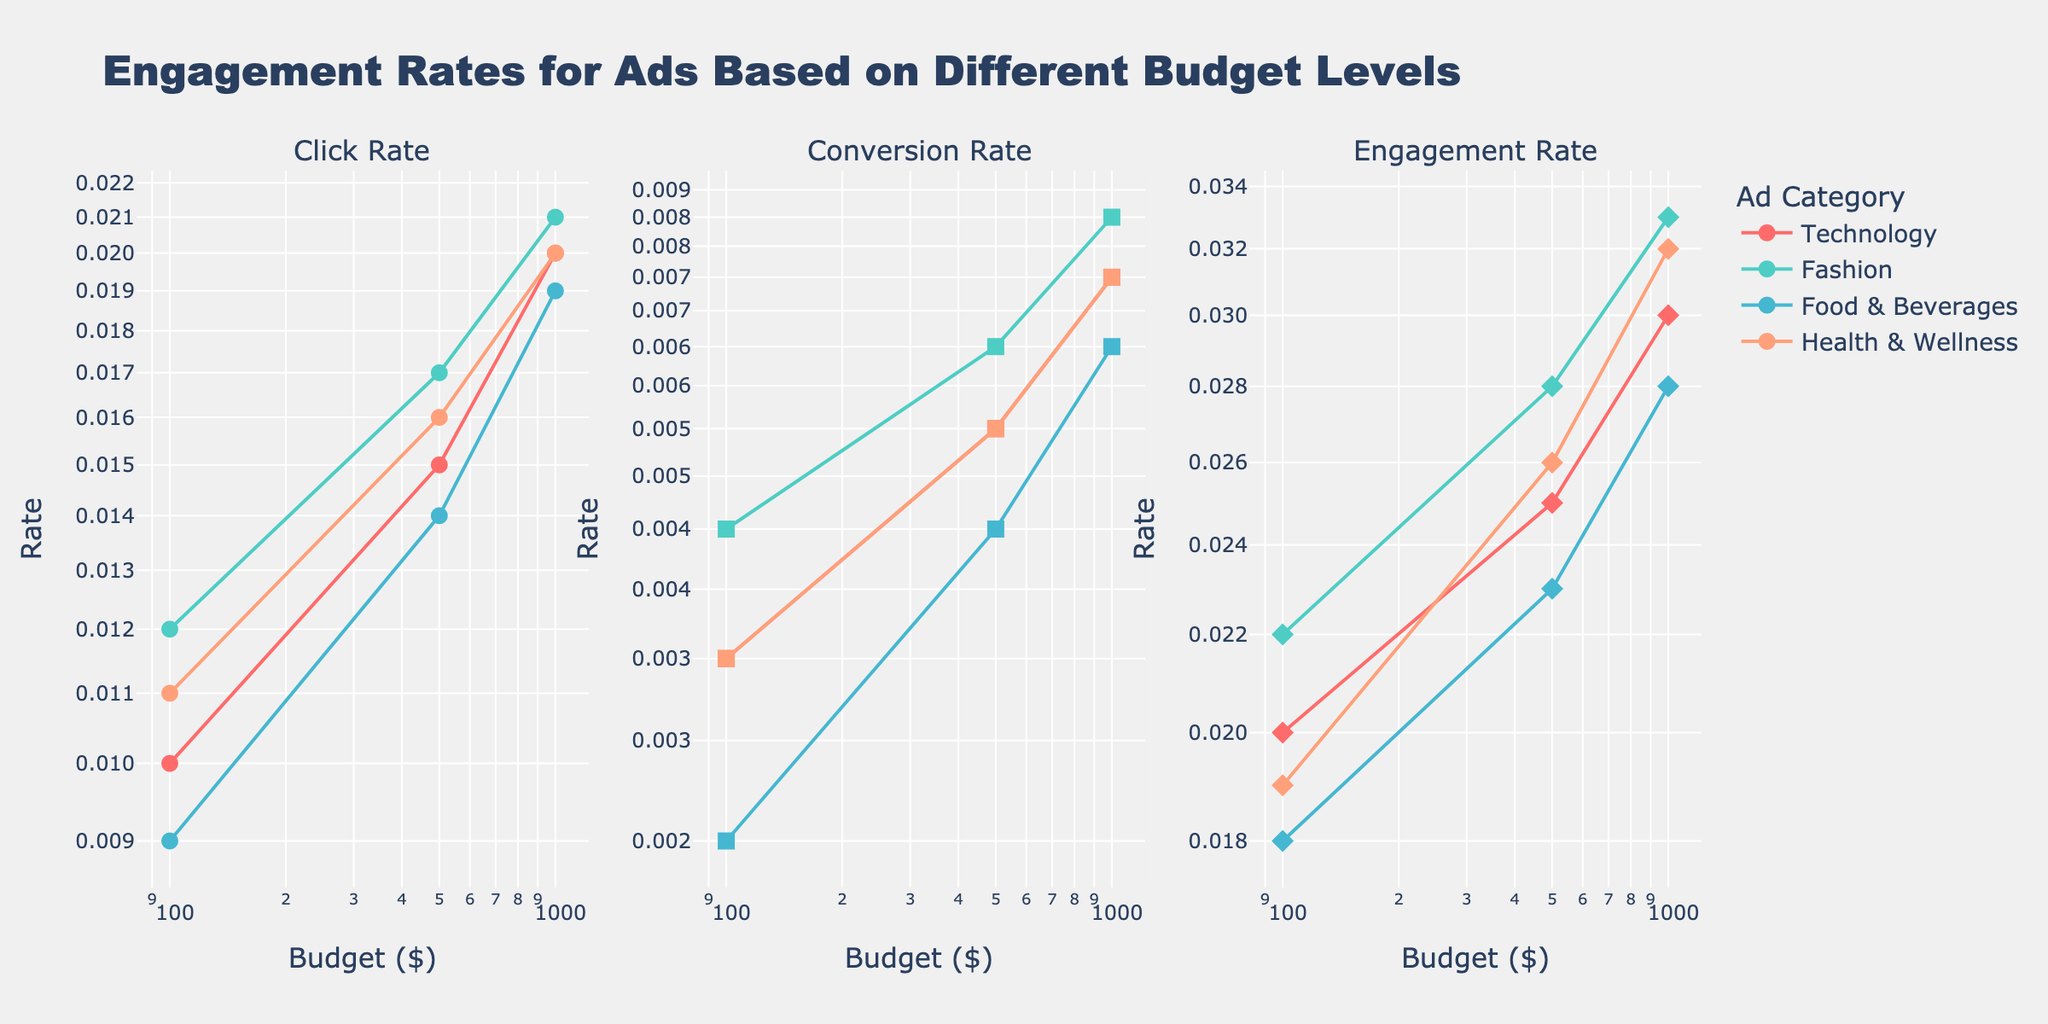What's the title of the figure? The title is displayed at the top of the figure and typically highlights the main topic or insight the chart is intended to convey. In this case, it is "Engagement Rates for Ads Based on Different Budget Levels."
Answer: Engagement Rates for Ads Based on Different Budget Levels How many ad categories are shown in the figure? By looking at the legend on the right-hand side of the figure, we can count the different colors representing each ad category. Here, we can see four categories listed: Technology, Fashion, Food & Beverages, and Health & Wellness.
Answer: 4 What type of scale is used on the axes for each subplot? Observing the tick marks and the spacing between them on both the x and y axes, we can identify that a logarithmic scale is used. The tick labels show exponential values, characteristic of a log scale.
Answer: Logarithmic Which ad category shows the highest engagement rate for a $1,000 budget? By concentrating on the rightmost subplot (Engagement Rate), we look for the point at $1,000 budget and compare the y-axis values. The highest point corresponds to the Fashion category with an engagement rate of 0.033.
Answer: Fashion How does the technology category's conversion rate change between $100 and $1,000? Focusing on the middle subplot (Conversion Rate) for the Technology category, we note the y-axis values at $100 and $1,000 budgets. The conversion rate increases from 0.003 to 0.007, showing growth.
Answer: It increases from 0.003 to 0.007 Which ad category has the least click rate at the $500 budget level? We need to examine the leftmost subplot (Click Rate) at the $500 budget level and compare the y-axis values. The Food & Beverages category shows the least click rate, with a value of 0.014.
Answer: Food & Beverages For which ad category does the engagement rate increase the most between the $100 and $1,000 budget levels? By comparing the engagement rates for all categories from $100 to $1,000 budgets (rightmost subplot), the category with the largest difference is Health & Wellness, which increases from 0.019 to 0.032, a difference of 0.013.
Answer: Health & Wellness Among the given ad categories, which one shows a consistent increase across all three metrics (click rate, conversion rate, engagement rate) as the budget increases from $100 to $1,000? By examining all three subplots (click rate, conversion rate, engagement rate) for consistency across all budget levels, we find that the Fashion category shows a uniform increase in all metrics from $100 to $1,000.
Answer: Fashion Do any of the ad categories show a decreasing trend for any metric as the budget increases? Review each subplot for any lines that slope downward as the budget (on the x-axis) increases. None of the ad categories show a decreasing trend; all metrics increase with the budget for every category.
Answer: No 